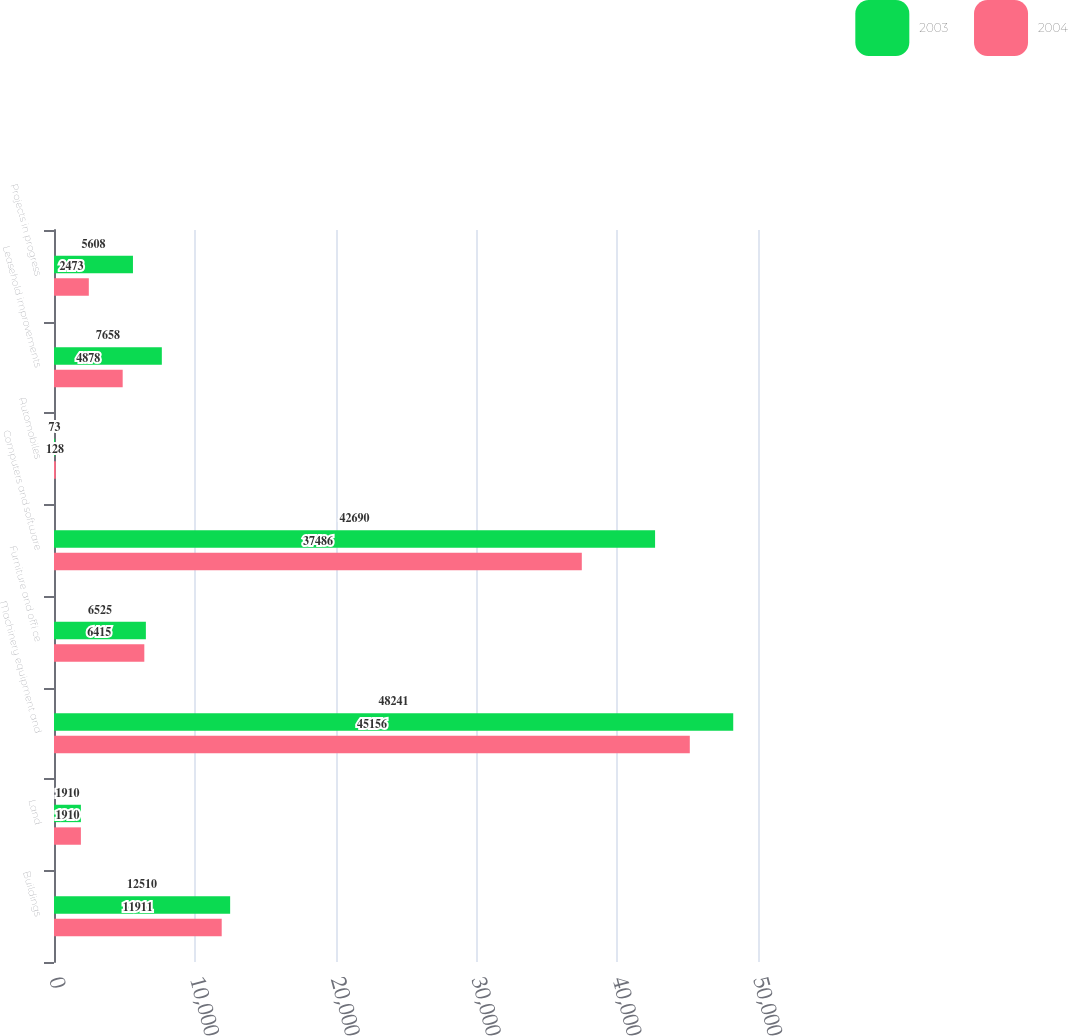<chart> <loc_0><loc_0><loc_500><loc_500><stacked_bar_chart><ecel><fcel>Buildings<fcel>Land<fcel>Machinery equipment and<fcel>Furniture and offi ce<fcel>Computers and software<fcel>Automobiles<fcel>Leasehold improvements<fcel>Projects in progress<nl><fcel>2003<fcel>12510<fcel>1910<fcel>48241<fcel>6525<fcel>42690<fcel>73<fcel>7658<fcel>5608<nl><fcel>2004<fcel>11911<fcel>1910<fcel>45156<fcel>6415<fcel>37486<fcel>128<fcel>4878<fcel>2473<nl></chart> 